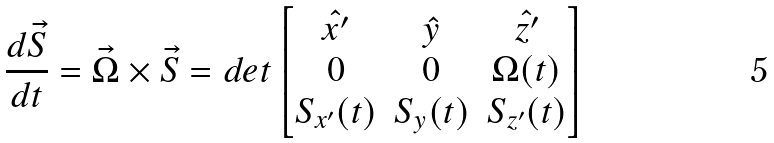Convert formula to latex. <formula><loc_0><loc_0><loc_500><loc_500>\frac { d \vec { S } } { d t } = \vec { \Omega } \times \vec { S } = d e t \left [ \begin{matrix} \hat { x ^ { \prime } } & \hat { y } & \hat { z ^ { \prime } } \\ 0 & 0 & \Omega ( t ) \\ S _ { x ^ { \prime } } ( t ) & S _ { y } ( t ) & S _ { z ^ { \prime } } ( t ) \end{matrix} \right ]</formula> 